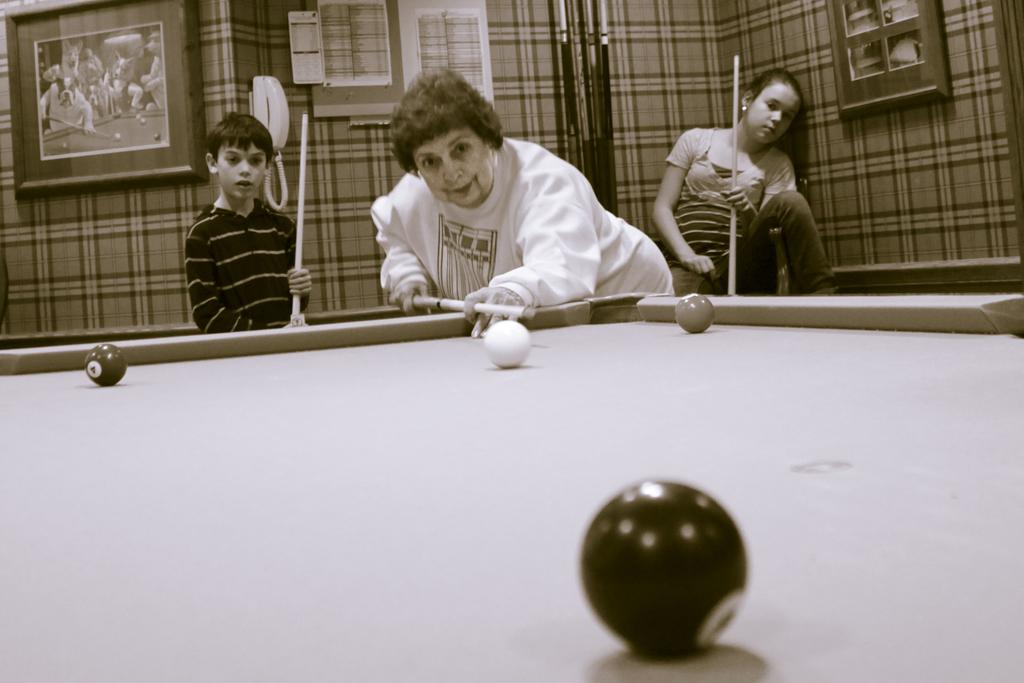How many people are present in the image? There are three people in the image. What are the people holding in their hands? The people are holding sticks in their hands. What can be seen on the table in the image? There are balls on a tennis table. What objects can be seen in the background of the image? There are frames, a telephone, and papers in the background. What type of gun is being exchanged between the people in the image? There is no gun present in the image; the people are holding sticks, which are likely tennis rackets. Is there a shop visible in the image? No, there is no shop present in the image. 